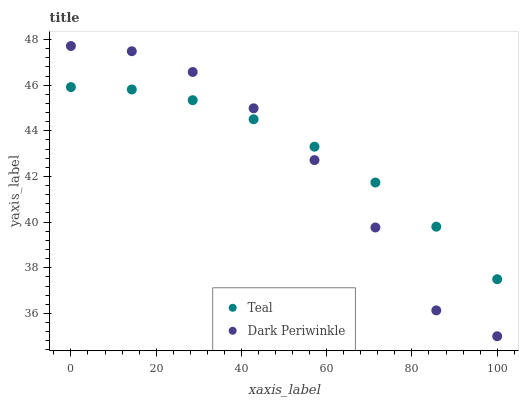Does Dark Periwinkle have the minimum area under the curve?
Answer yes or no. Yes. Does Teal have the maximum area under the curve?
Answer yes or no. Yes. Does Teal have the minimum area under the curve?
Answer yes or no. No. Is Teal the smoothest?
Answer yes or no. Yes. Is Dark Periwinkle the roughest?
Answer yes or no. Yes. Is Teal the roughest?
Answer yes or no. No. Does Dark Periwinkle have the lowest value?
Answer yes or no. Yes. Does Teal have the lowest value?
Answer yes or no. No. Does Dark Periwinkle have the highest value?
Answer yes or no. Yes. Does Teal have the highest value?
Answer yes or no. No. Does Dark Periwinkle intersect Teal?
Answer yes or no. Yes. Is Dark Periwinkle less than Teal?
Answer yes or no. No. Is Dark Periwinkle greater than Teal?
Answer yes or no. No. 